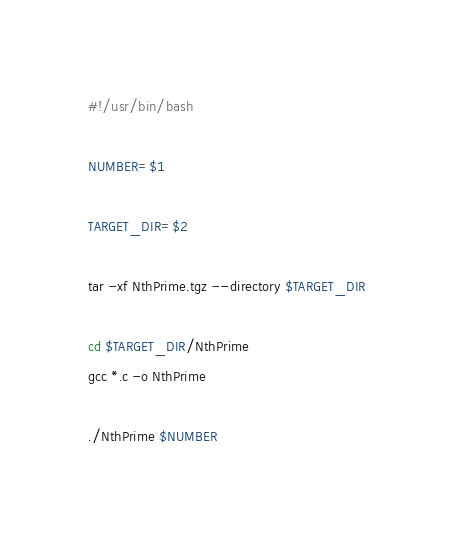Convert code to text. <code><loc_0><loc_0><loc_500><loc_500><_Bash_>#!/usr/bin/bash

NUMBER=$1

TARGET_DIR=$2

tar -xf NthPrime.tgz --directory $TARGET_DIR

cd $TARGET_DIR/NthPrime
gcc *.c -o NthPrime

./NthPrime $NUMBER


</code> 